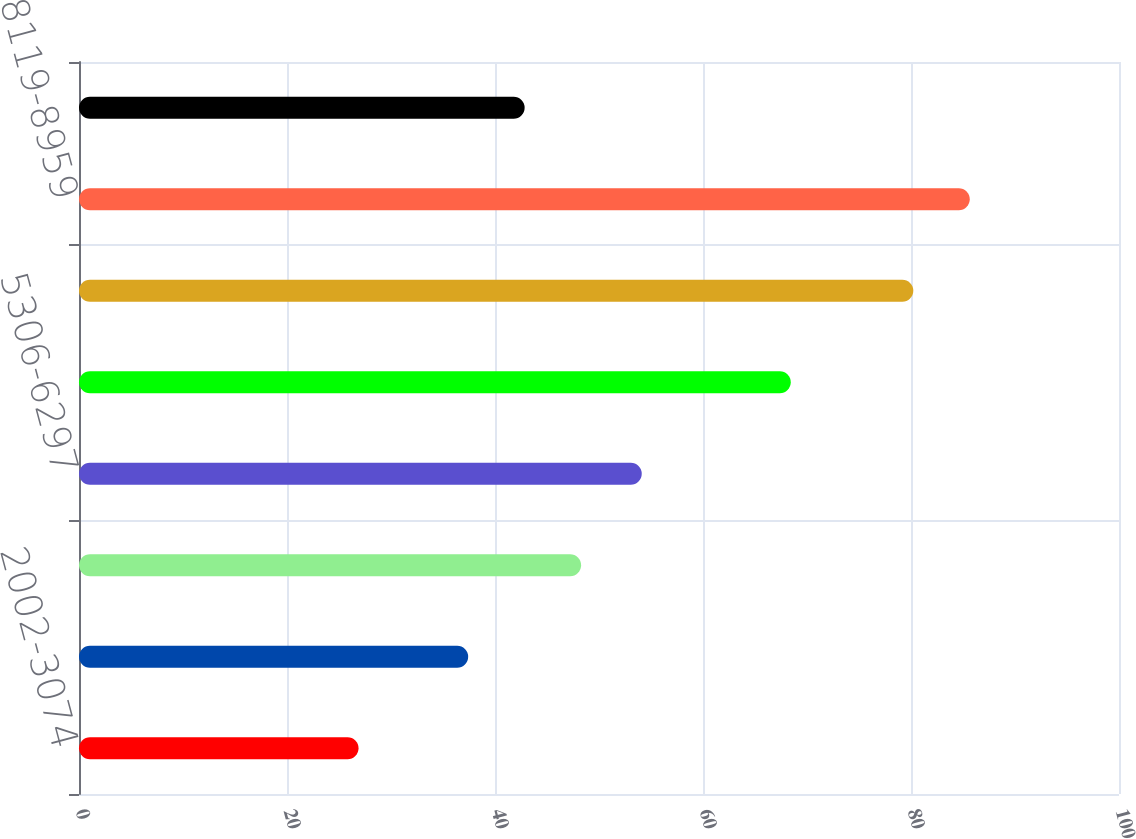<chart> <loc_0><loc_0><loc_500><loc_500><bar_chart><fcel>2002-3074<fcel>3074-4093<fcel>4272-5182<fcel>5306-6297<fcel>6452-7182<fcel>7338-8047<fcel>8119-8959<fcel>Total<nl><fcel>26.88<fcel>37.42<fcel>48.28<fcel>54.11<fcel>68.44<fcel>80.22<fcel>85.65<fcel>42.85<nl></chart> 